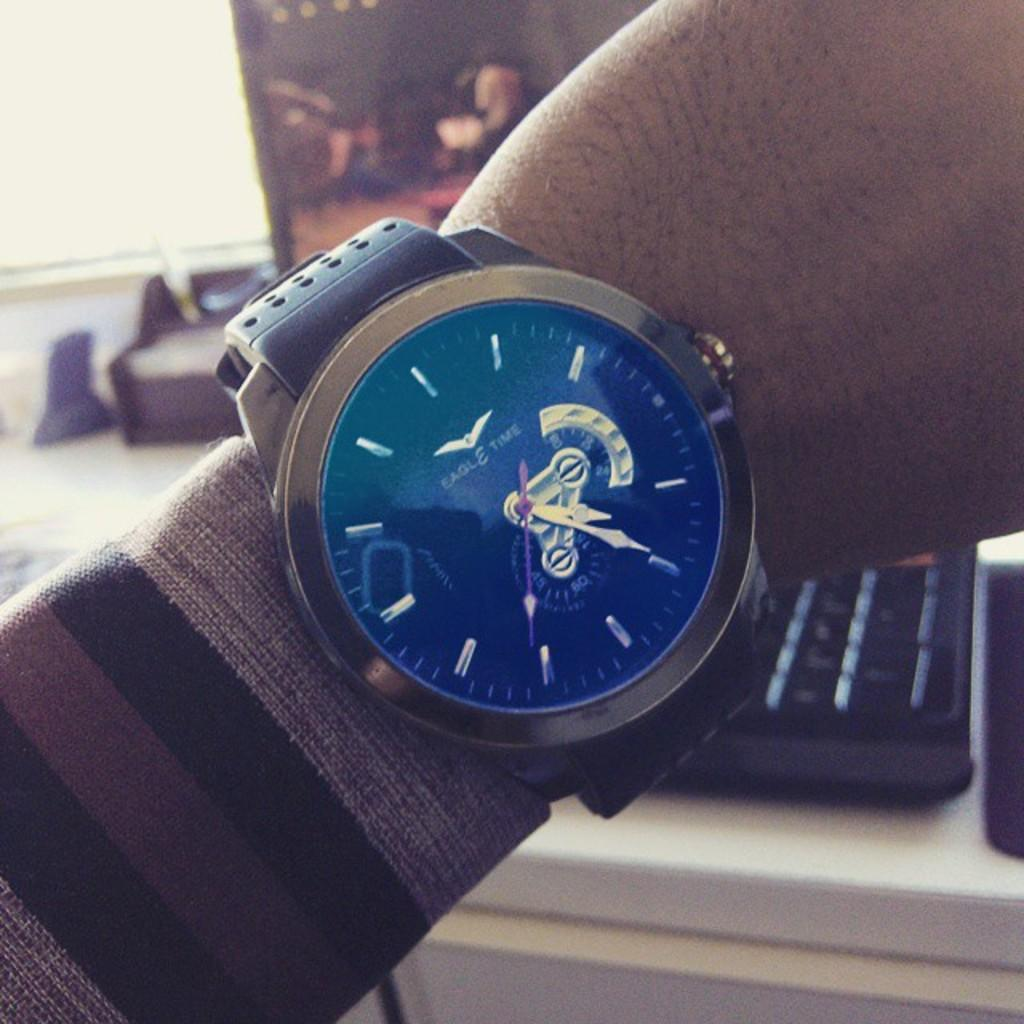Provide a one-sentence caption for the provided image. Person holding up their watch which says Eagle Time on it. 